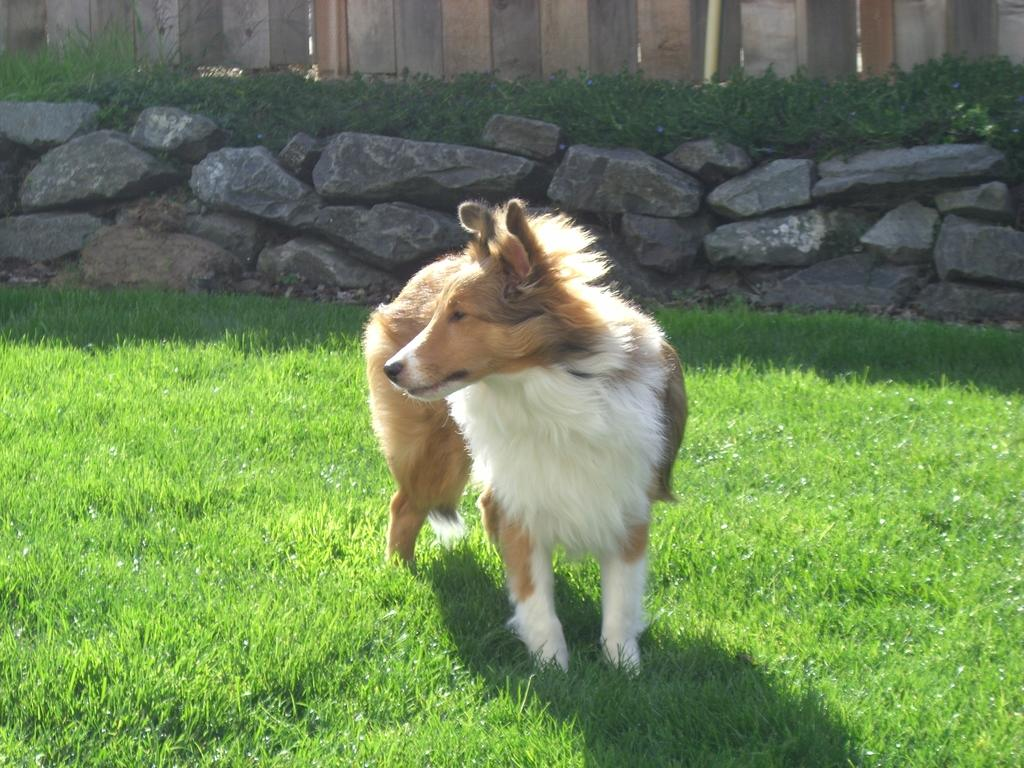What animal can be seen in the garden in the image? There is a dog in the garden in the image. What direction is the dog looking in? The dog is looking to the left side. What can be seen in the background of the image? There are rocks and plants in the background of the image. What type of wall is visible at the top of the image? There is a wall made of wood at the top of the image. What type of locket is the dog wearing in the image? There is no locket visible on the dog in the image. What type of view can be seen from the top of the wall in the image? The image does not show a view from the top of the wall; it only shows the wall itself. 